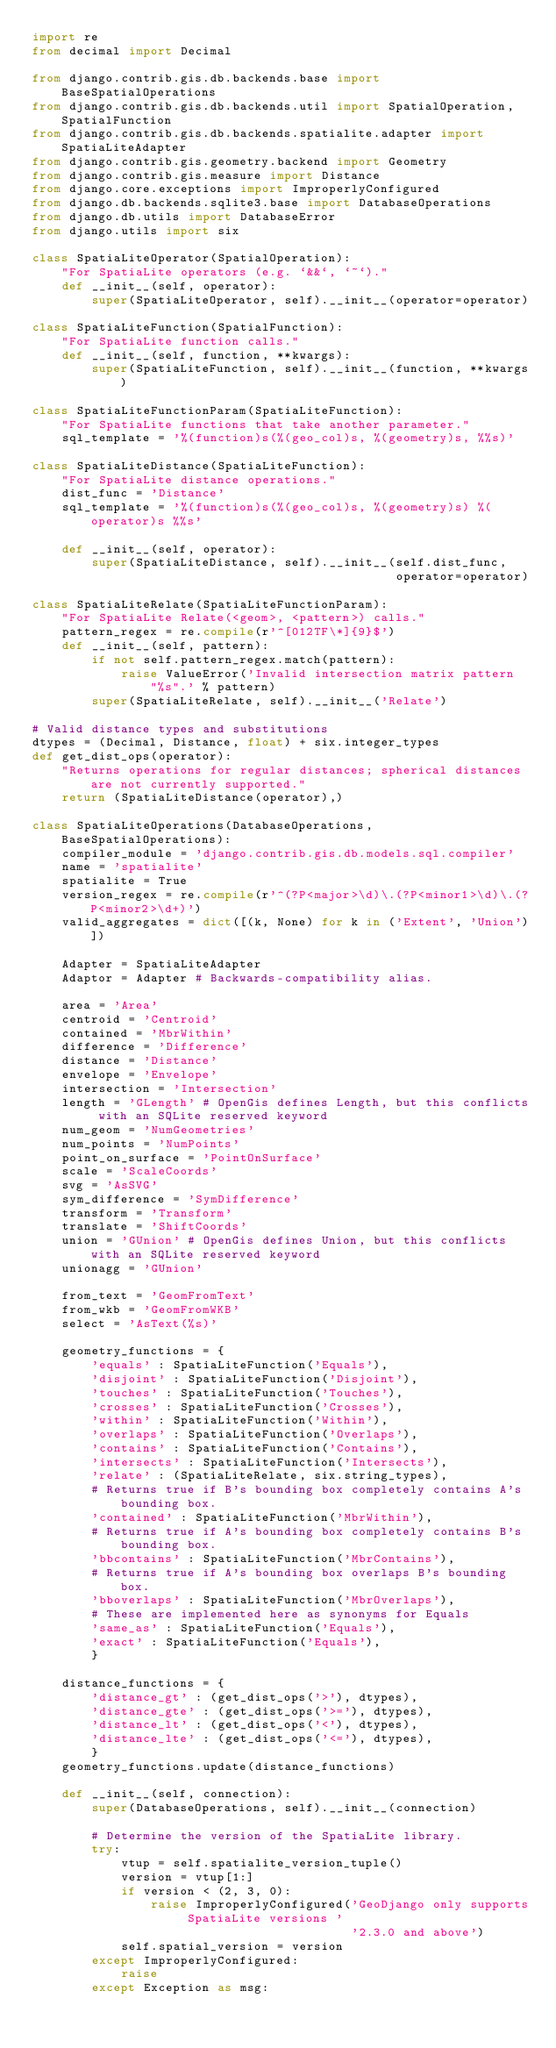<code> <loc_0><loc_0><loc_500><loc_500><_Python_>import re
from decimal import Decimal

from django.contrib.gis.db.backends.base import BaseSpatialOperations
from django.contrib.gis.db.backends.util import SpatialOperation, SpatialFunction
from django.contrib.gis.db.backends.spatialite.adapter import SpatiaLiteAdapter
from django.contrib.gis.geometry.backend import Geometry
from django.contrib.gis.measure import Distance
from django.core.exceptions import ImproperlyConfigured
from django.db.backends.sqlite3.base import DatabaseOperations
from django.db.utils import DatabaseError
from django.utils import six

class SpatiaLiteOperator(SpatialOperation):
    "For SpatiaLite operators (e.g. `&&`, `~`)."
    def __init__(self, operator):
        super(SpatiaLiteOperator, self).__init__(operator=operator)

class SpatiaLiteFunction(SpatialFunction):
    "For SpatiaLite function calls."
    def __init__(self, function, **kwargs):
        super(SpatiaLiteFunction, self).__init__(function, **kwargs)

class SpatiaLiteFunctionParam(SpatiaLiteFunction):
    "For SpatiaLite functions that take another parameter."
    sql_template = '%(function)s(%(geo_col)s, %(geometry)s, %%s)'

class SpatiaLiteDistance(SpatiaLiteFunction):
    "For SpatiaLite distance operations."
    dist_func = 'Distance'
    sql_template = '%(function)s(%(geo_col)s, %(geometry)s) %(operator)s %%s'

    def __init__(self, operator):
        super(SpatiaLiteDistance, self).__init__(self.dist_func,
                                                 operator=operator)

class SpatiaLiteRelate(SpatiaLiteFunctionParam):
    "For SpatiaLite Relate(<geom>, <pattern>) calls."
    pattern_regex = re.compile(r'^[012TF\*]{9}$')
    def __init__(self, pattern):
        if not self.pattern_regex.match(pattern):
            raise ValueError('Invalid intersection matrix pattern "%s".' % pattern)
        super(SpatiaLiteRelate, self).__init__('Relate')

# Valid distance types and substitutions
dtypes = (Decimal, Distance, float) + six.integer_types
def get_dist_ops(operator):
    "Returns operations for regular distances; spherical distances are not currently supported."
    return (SpatiaLiteDistance(operator),)

class SpatiaLiteOperations(DatabaseOperations, BaseSpatialOperations):
    compiler_module = 'django.contrib.gis.db.models.sql.compiler'
    name = 'spatialite'
    spatialite = True
    version_regex = re.compile(r'^(?P<major>\d)\.(?P<minor1>\d)\.(?P<minor2>\d+)')
    valid_aggregates = dict([(k, None) for k in ('Extent', 'Union')])

    Adapter = SpatiaLiteAdapter
    Adaptor = Adapter # Backwards-compatibility alias.

    area = 'Area'
    centroid = 'Centroid'
    contained = 'MbrWithin'
    difference = 'Difference'
    distance = 'Distance'
    envelope = 'Envelope'
    intersection = 'Intersection'
    length = 'GLength' # OpenGis defines Length, but this conflicts with an SQLite reserved keyword
    num_geom = 'NumGeometries'
    num_points = 'NumPoints'
    point_on_surface = 'PointOnSurface'
    scale = 'ScaleCoords'
    svg = 'AsSVG'
    sym_difference = 'SymDifference'
    transform = 'Transform'
    translate = 'ShiftCoords'
    union = 'GUnion' # OpenGis defines Union, but this conflicts with an SQLite reserved keyword
    unionagg = 'GUnion'

    from_text = 'GeomFromText'
    from_wkb = 'GeomFromWKB'
    select = 'AsText(%s)'

    geometry_functions = {
        'equals' : SpatiaLiteFunction('Equals'),
        'disjoint' : SpatiaLiteFunction('Disjoint'),
        'touches' : SpatiaLiteFunction('Touches'),
        'crosses' : SpatiaLiteFunction('Crosses'),
        'within' : SpatiaLiteFunction('Within'),
        'overlaps' : SpatiaLiteFunction('Overlaps'),
        'contains' : SpatiaLiteFunction('Contains'),
        'intersects' : SpatiaLiteFunction('Intersects'),
        'relate' : (SpatiaLiteRelate, six.string_types),
        # Returns true if B's bounding box completely contains A's bounding box.
        'contained' : SpatiaLiteFunction('MbrWithin'),
        # Returns true if A's bounding box completely contains B's bounding box.
        'bbcontains' : SpatiaLiteFunction('MbrContains'),
        # Returns true if A's bounding box overlaps B's bounding box.
        'bboverlaps' : SpatiaLiteFunction('MbrOverlaps'),
        # These are implemented here as synonyms for Equals
        'same_as' : SpatiaLiteFunction('Equals'),
        'exact' : SpatiaLiteFunction('Equals'),
        }

    distance_functions = {
        'distance_gt' : (get_dist_ops('>'), dtypes),
        'distance_gte' : (get_dist_ops('>='), dtypes),
        'distance_lt' : (get_dist_ops('<'), dtypes),
        'distance_lte' : (get_dist_ops('<='), dtypes),
        }
    geometry_functions.update(distance_functions)

    def __init__(self, connection):
        super(DatabaseOperations, self).__init__(connection)

        # Determine the version of the SpatiaLite library.
        try:
            vtup = self.spatialite_version_tuple()
            version = vtup[1:]
            if version < (2, 3, 0):
                raise ImproperlyConfigured('GeoDjango only supports SpatiaLite versions '
                                           '2.3.0 and above')
            self.spatial_version = version
        except ImproperlyConfigured:
            raise
        except Exception as msg:</code> 